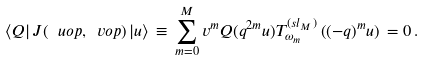<formula> <loc_0><loc_0><loc_500><loc_500>\langle Q | \, J ( \ u o p , \ v o p ) \, | u \rangle \, \equiv \, \sum _ { m = 0 } ^ { M } v ^ { m } Q ( q ^ { 2 m } u ) T _ { \omega _ { m } } ^ { ( s l _ { M } ) } \left ( ( - q ) ^ { m } u \right ) \, = 0 \, .</formula> 